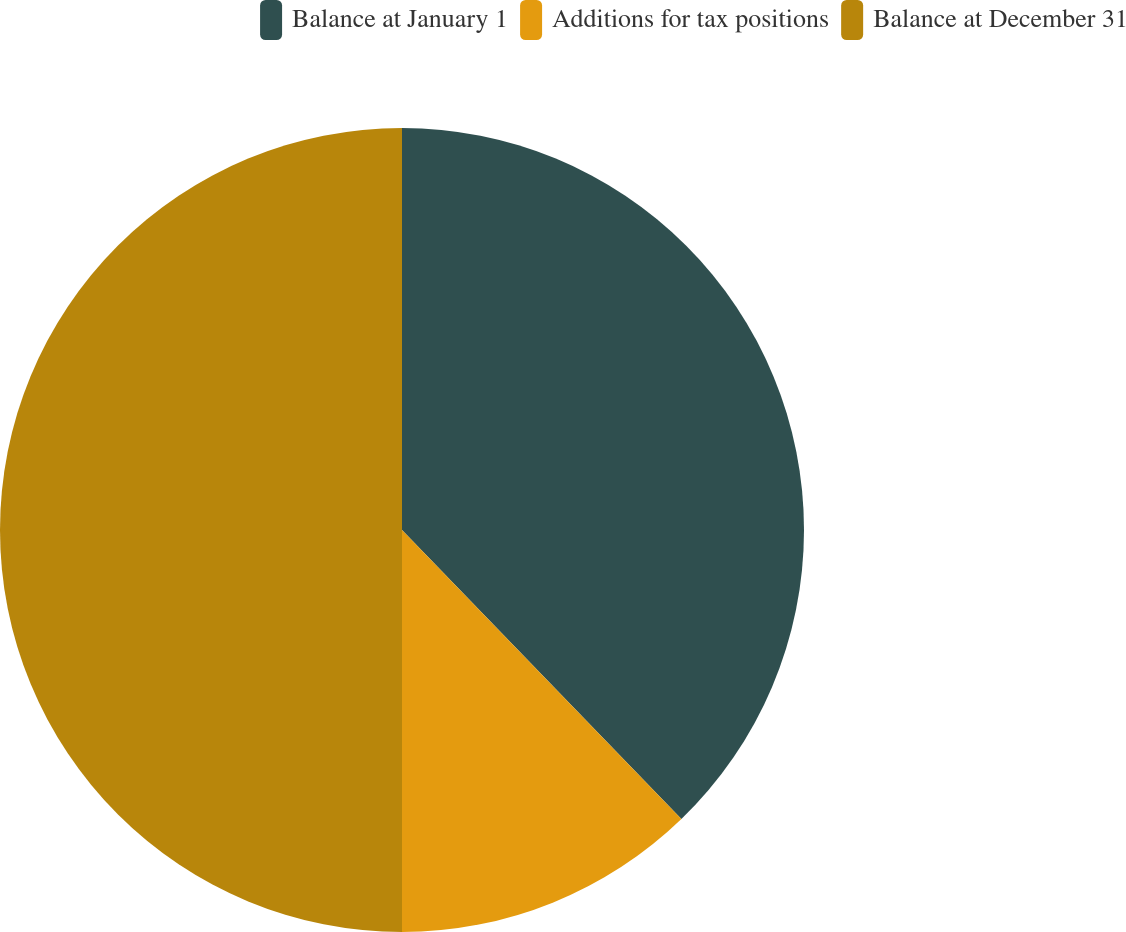Convert chart to OTSL. <chart><loc_0><loc_0><loc_500><loc_500><pie_chart><fcel>Balance at January 1<fcel>Additions for tax positions<fcel>Balance at December 31<nl><fcel>37.77%<fcel>12.23%<fcel>50.0%<nl></chart> 